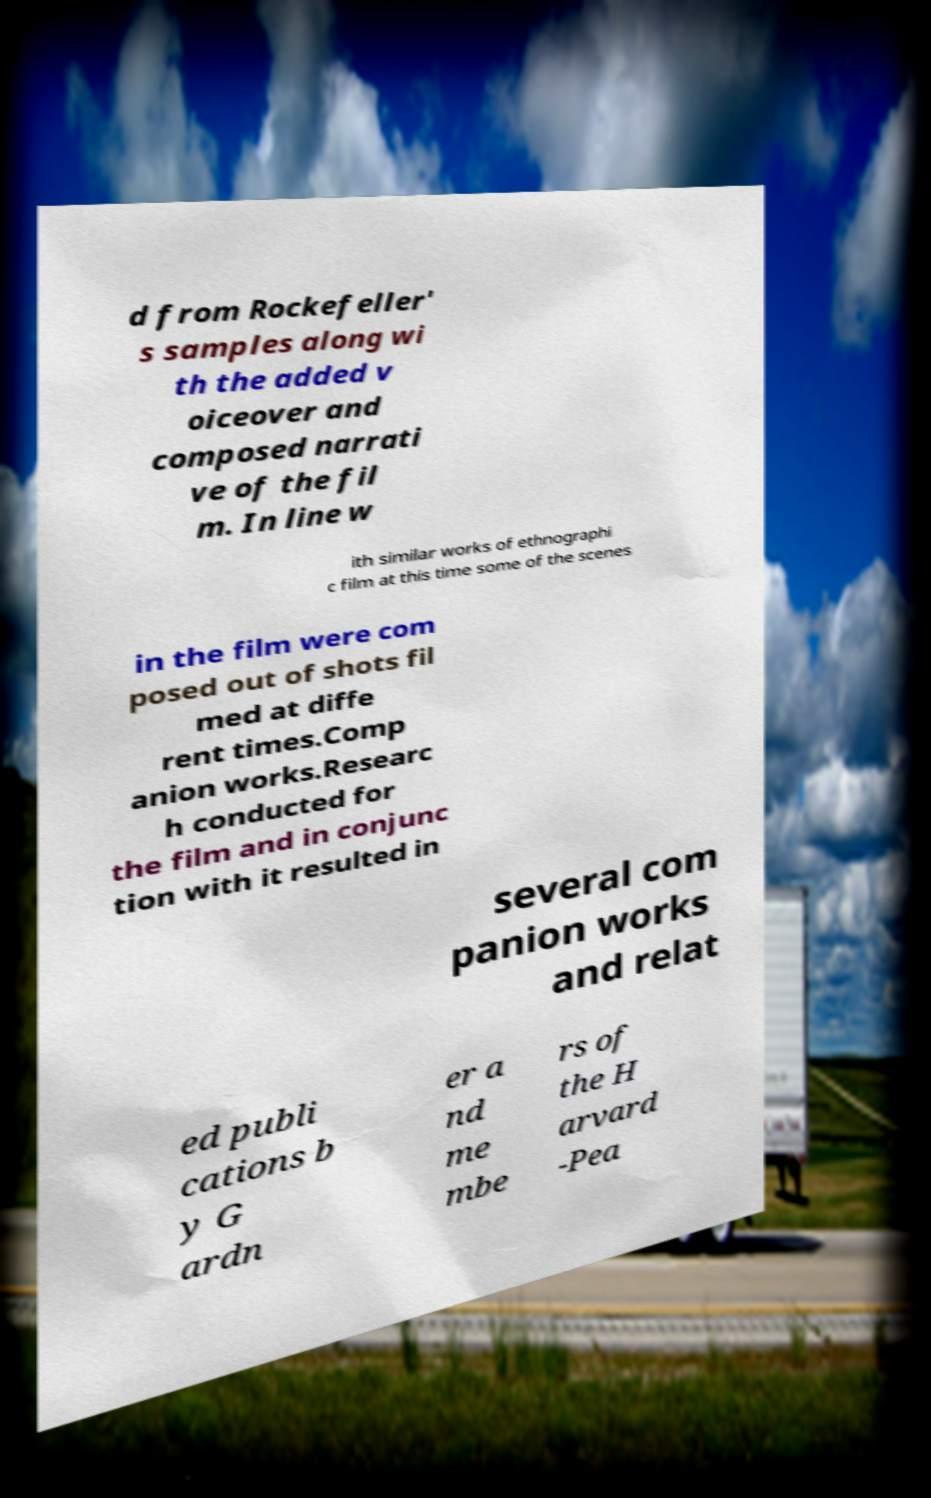Please identify and transcribe the text found in this image. d from Rockefeller' s samples along wi th the added v oiceover and composed narrati ve of the fil m. In line w ith similar works of ethnographi c film at this time some of the scenes in the film were com posed out of shots fil med at diffe rent times.Comp anion works.Researc h conducted for the film and in conjunc tion with it resulted in several com panion works and relat ed publi cations b y G ardn er a nd me mbe rs of the H arvard -Pea 